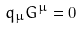<formula> <loc_0><loc_0><loc_500><loc_500>q _ { \mu } G ^ { \mu } = 0</formula> 